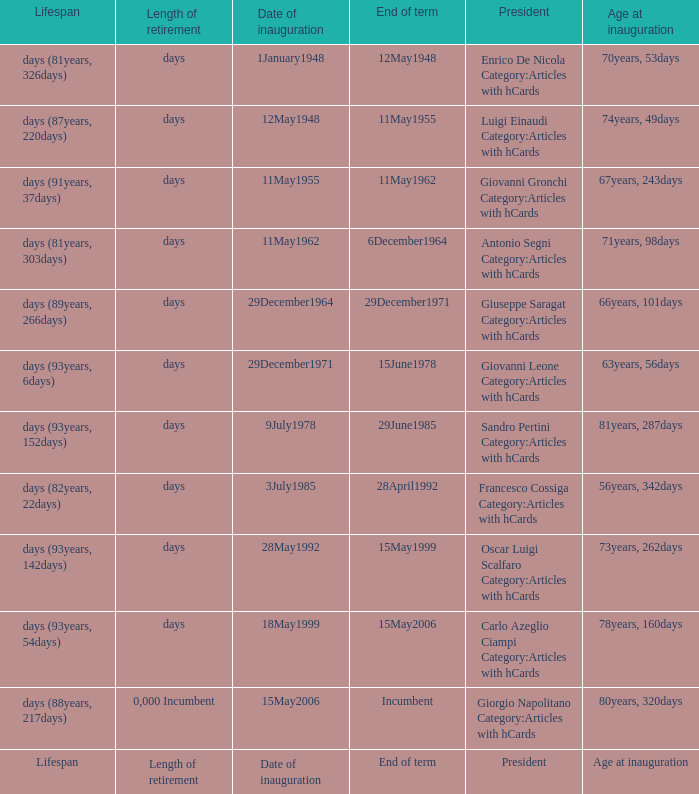What is the Date of inauguration of the President with an Age at inauguration of 73years, 262days? 28May1992. 